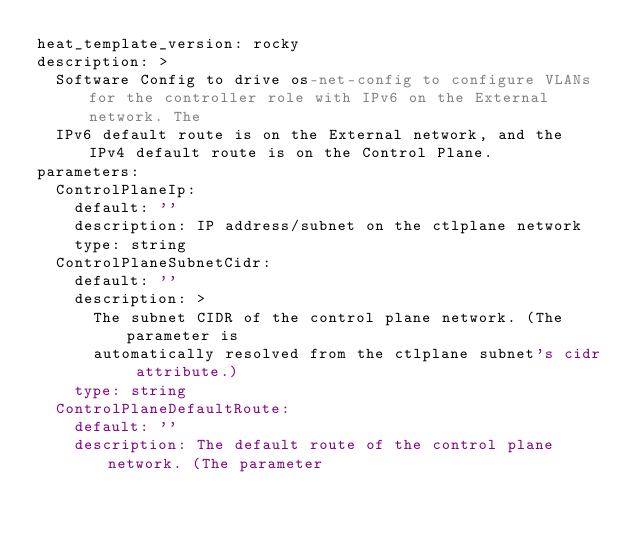<code> <loc_0><loc_0><loc_500><loc_500><_YAML_>heat_template_version: rocky
description: >
  Software Config to drive os-net-config to configure VLANs for the controller role with IPv6 on the External network. The
  IPv6 default route is on the External network, and the IPv4 default route is on the Control Plane.
parameters:
  ControlPlaneIp:
    default: ''
    description: IP address/subnet on the ctlplane network
    type: string
  ControlPlaneSubnetCidr:
    default: ''
    description: >
      The subnet CIDR of the control plane network. (The parameter is
      automatically resolved from the ctlplane subnet's cidr attribute.)
    type: string
  ControlPlaneDefaultRoute:
    default: ''
    description: The default route of the control plane network. (The parameter</code> 